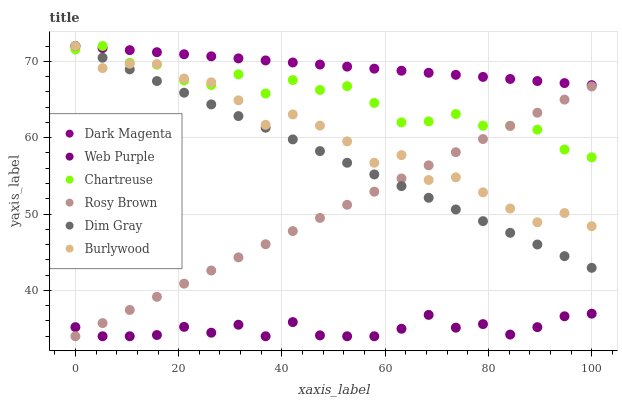Does Web Purple have the minimum area under the curve?
Answer yes or no. Yes. Does Dark Magenta have the maximum area under the curve?
Answer yes or no. Yes. Does Burlywood have the minimum area under the curve?
Answer yes or no. No. Does Burlywood have the maximum area under the curve?
Answer yes or no. No. Is Rosy Brown the smoothest?
Answer yes or no. Yes. Is Burlywood the roughest?
Answer yes or no. Yes. Is Dark Magenta the smoothest?
Answer yes or no. No. Is Dark Magenta the roughest?
Answer yes or no. No. Does Rosy Brown have the lowest value?
Answer yes or no. Yes. Does Burlywood have the lowest value?
Answer yes or no. No. Does Chartreuse have the highest value?
Answer yes or no. Yes. Does Rosy Brown have the highest value?
Answer yes or no. No. Is Web Purple less than Dark Magenta?
Answer yes or no. Yes. Is Chartreuse greater than Web Purple?
Answer yes or no. Yes. Does Rosy Brown intersect Web Purple?
Answer yes or no. Yes. Is Rosy Brown less than Web Purple?
Answer yes or no. No. Is Rosy Brown greater than Web Purple?
Answer yes or no. No. Does Web Purple intersect Dark Magenta?
Answer yes or no. No. 